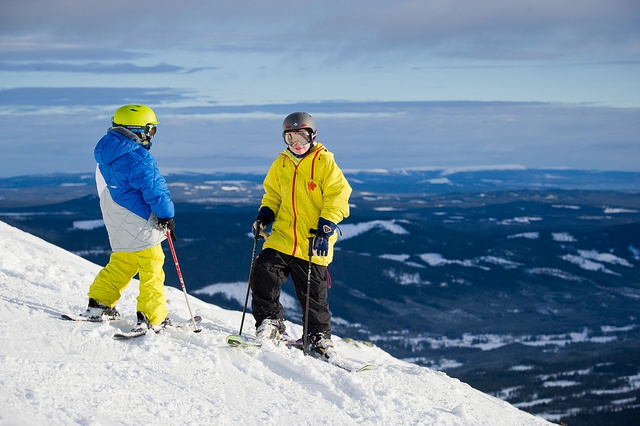Describe the objects in this image and their specific colors. I can see people in gray, black, gold, and olive tones, people in gray, blue, darkgray, olive, and gold tones, skis in gray, lightgray, darkgray, and black tones, and skis in gray, lightgray, darkgray, and beige tones in this image. 